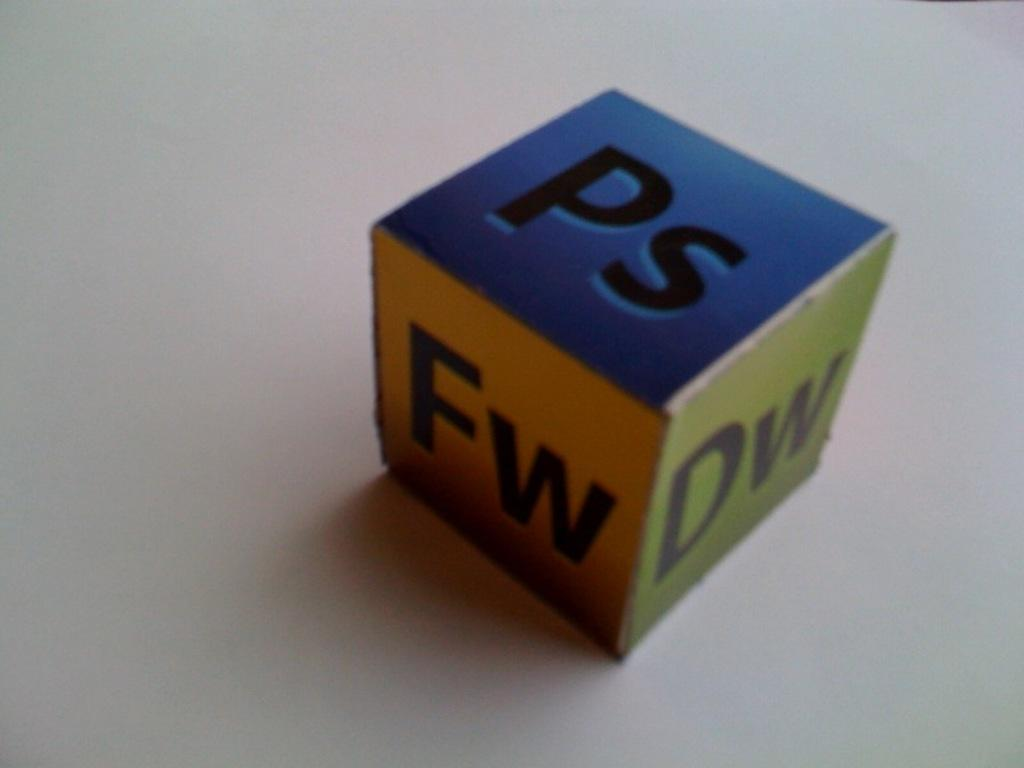What is the main object in the image? There is a colorful box in the image. Where is the box located? The box is placed on a white object. What can be seen on the surface of the box? There is text visible on the box. How many women are holding scissors in the image? There are no women or scissors present in the image; it only features a colorful box placed on a white object with text on it. 